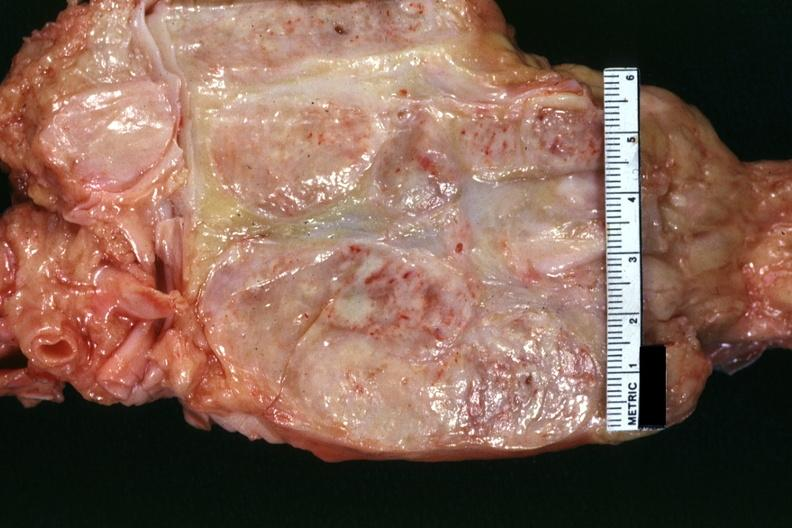what is present?
Answer the question using a single word or phrase. Lymph node 